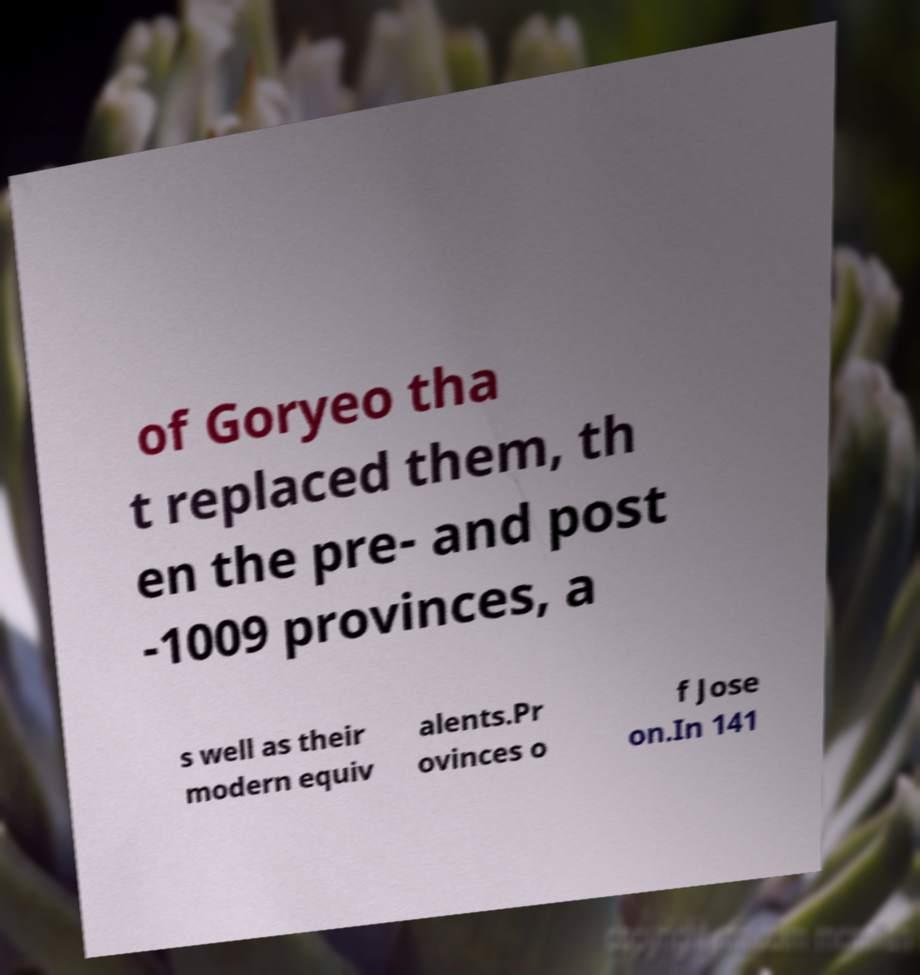For documentation purposes, I need the text within this image transcribed. Could you provide that? of Goryeo tha t replaced them, th en the pre- and post -1009 provinces, a s well as their modern equiv alents.Pr ovinces o f Jose on.In 141 